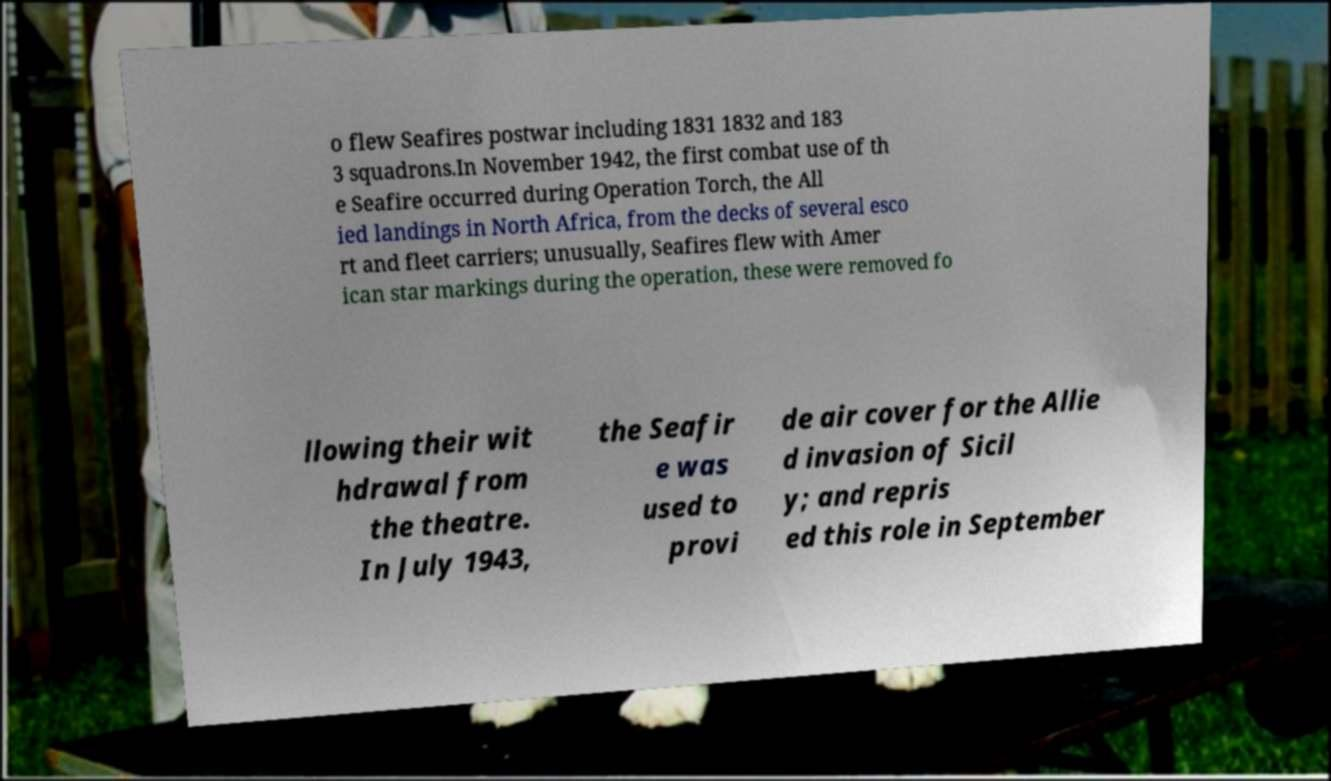What messages or text are displayed in this image? I need them in a readable, typed format. o flew Seafires postwar including 1831 1832 and 183 3 squadrons.In November 1942, the first combat use of th e Seafire occurred during Operation Torch, the All ied landings in North Africa, from the decks of several esco rt and fleet carriers; unusually, Seafires flew with Amer ican star markings during the operation, these were removed fo llowing their wit hdrawal from the theatre. In July 1943, the Seafir e was used to provi de air cover for the Allie d invasion of Sicil y; and repris ed this role in September 